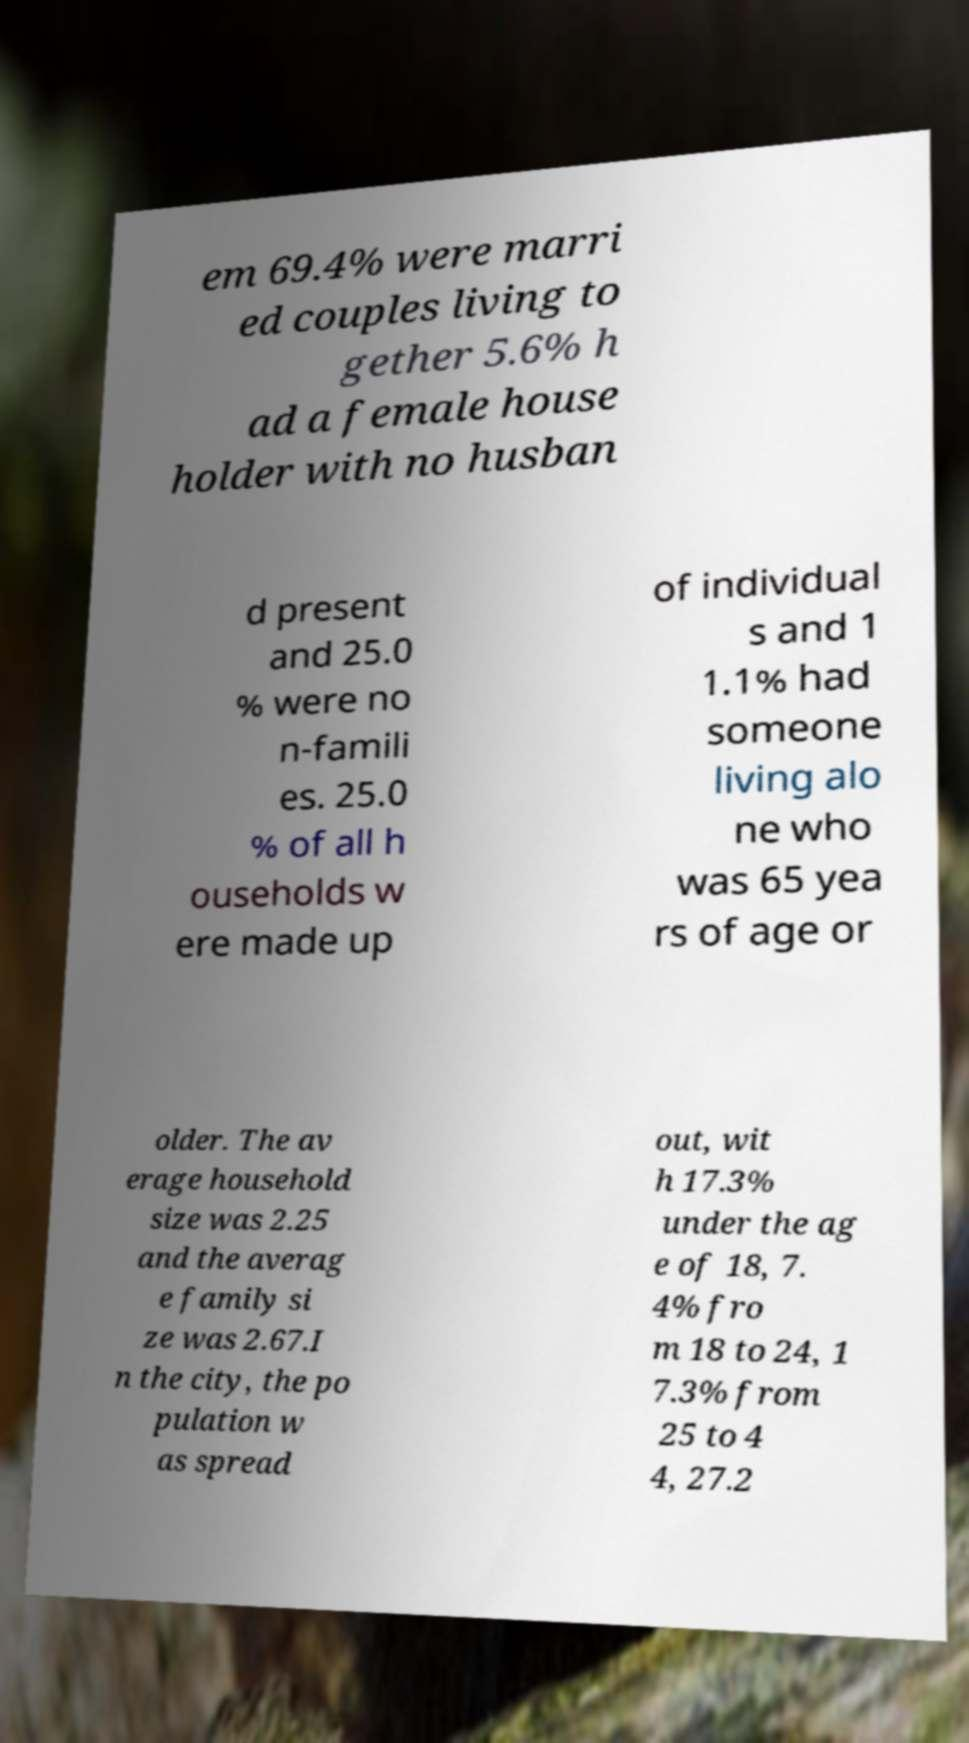Please identify and transcribe the text found in this image. em 69.4% were marri ed couples living to gether 5.6% h ad a female house holder with no husban d present and 25.0 % were no n-famili es. 25.0 % of all h ouseholds w ere made up of individual s and 1 1.1% had someone living alo ne who was 65 yea rs of age or older. The av erage household size was 2.25 and the averag e family si ze was 2.67.I n the city, the po pulation w as spread out, wit h 17.3% under the ag e of 18, 7. 4% fro m 18 to 24, 1 7.3% from 25 to 4 4, 27.2 